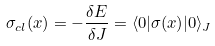Convert formula to latex. <formula><loc_0><loc_0><loc_500><loc_500>\sigma _ { c l } ( x ) = - \frac { \delta E } { \delta J } = \langle 0 | \sigma ( x ) | 0 \rangle _ { J }</formula> 